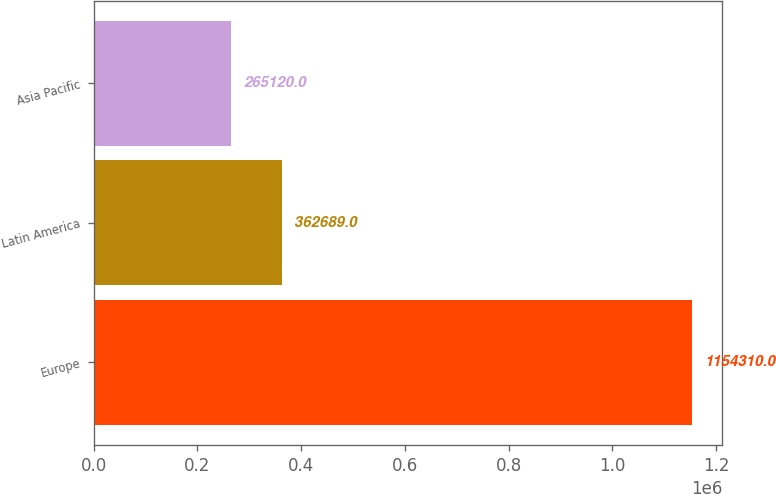<chart> <loc_0><loc_0><loc_500><loc_500><bar_chart><fcel>Europe<fcel>Latin America<fcel>Asia Pacific<nl><fcel>1.15431e+06<fcel>362689<fcel>265120<nl></chart> 